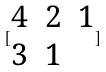Convert formula to latex. <formula><loc_0><loc_0><loc_500><loc_500>[ \begin{matrix} 4 & 2 & 1 \\ 3 & 1 \end{matrix} ]</formula> 